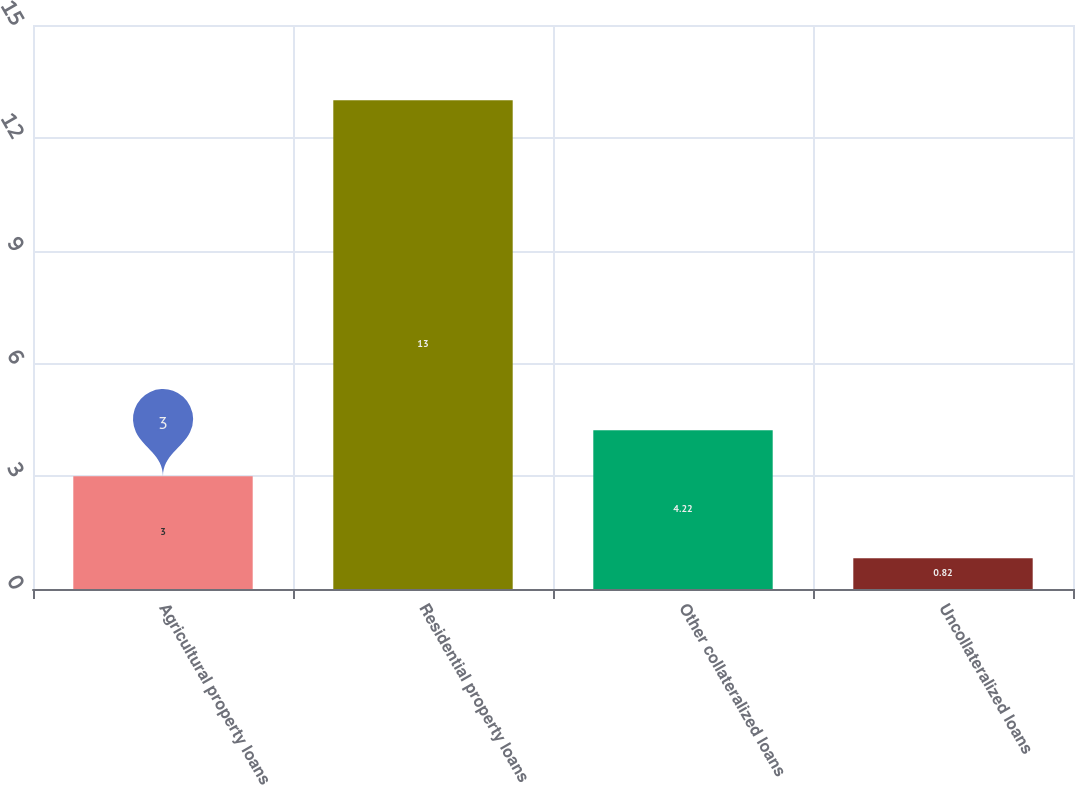<chart> <loc_0><loc_0><loc_500><loc_500><bar_chart><fcel>Agricultural property loans<fcel>Residential property loans<fcel>Other collateralized loans<fcel>Uncollateralized loans<nl><fcel>3<fcel>13<fcel>4.22<fcel>0.82<nl></chart> 